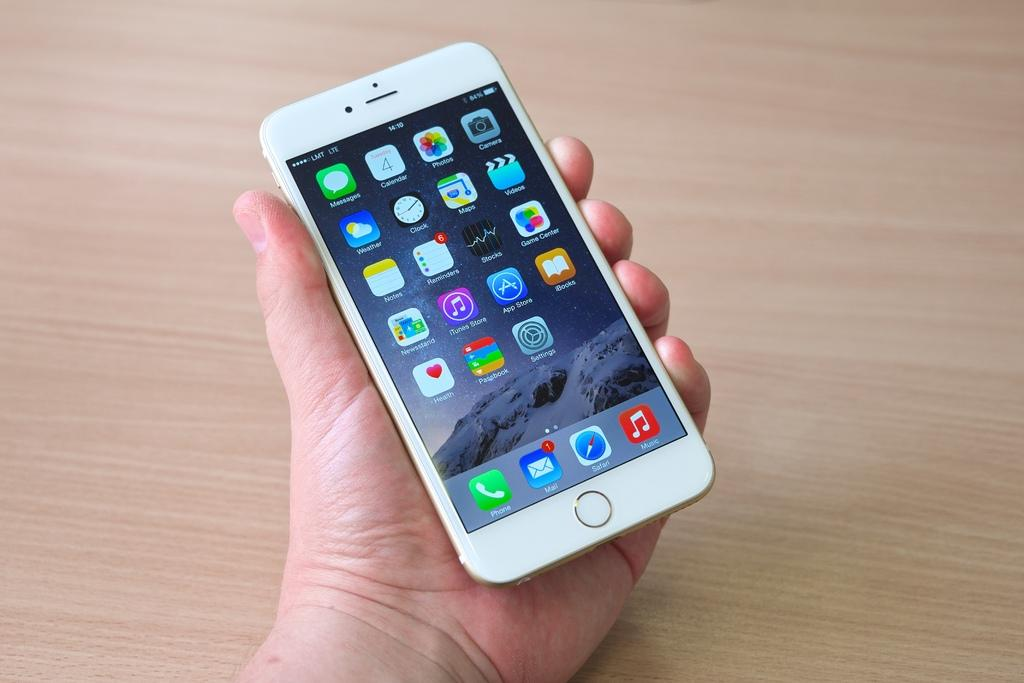<image>
Create a compact narrative representing the image presented. A person holding a white iphone and the email icon app shows one message 